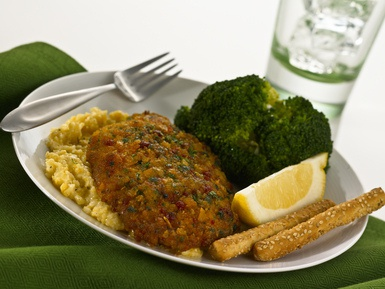Describe the objects in this image and their specific colors. I can see broccoli in white, black, darkgreen, and darkgray tones, cup in white, ivory, lightgray, darkgray, and olive tones, and fork in white, darkgray, gray, and lightgray tones in this image. 